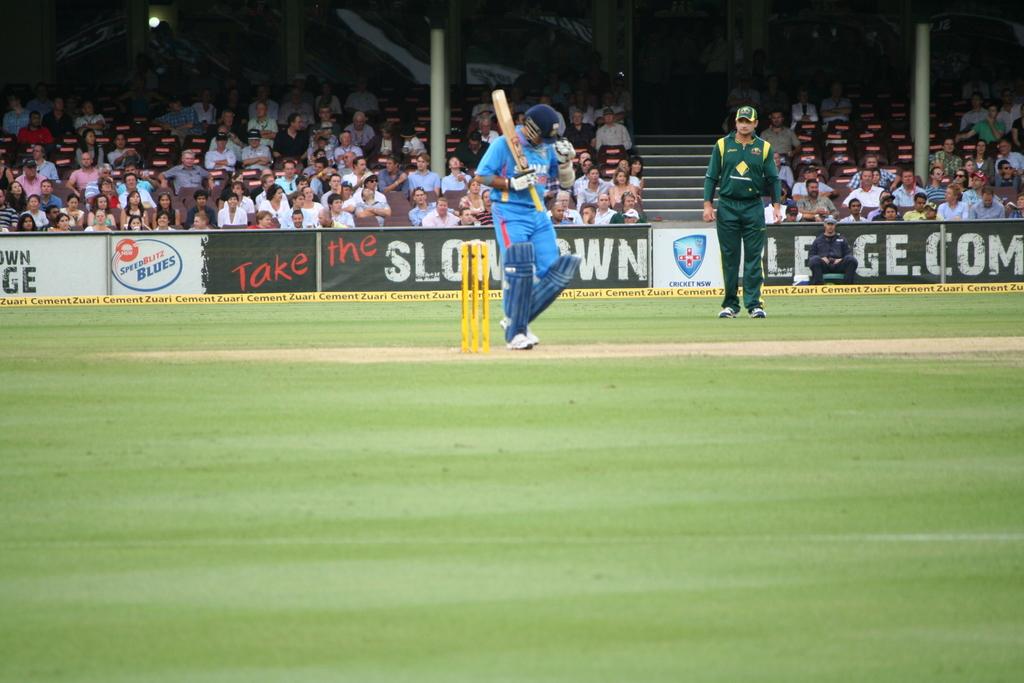Who is advertising in this stadium?
Offer a terse response. Speedblitz blues. What kind of blues is mentioned on the white sign?
Provide a short and direct response. Speedblitz. 